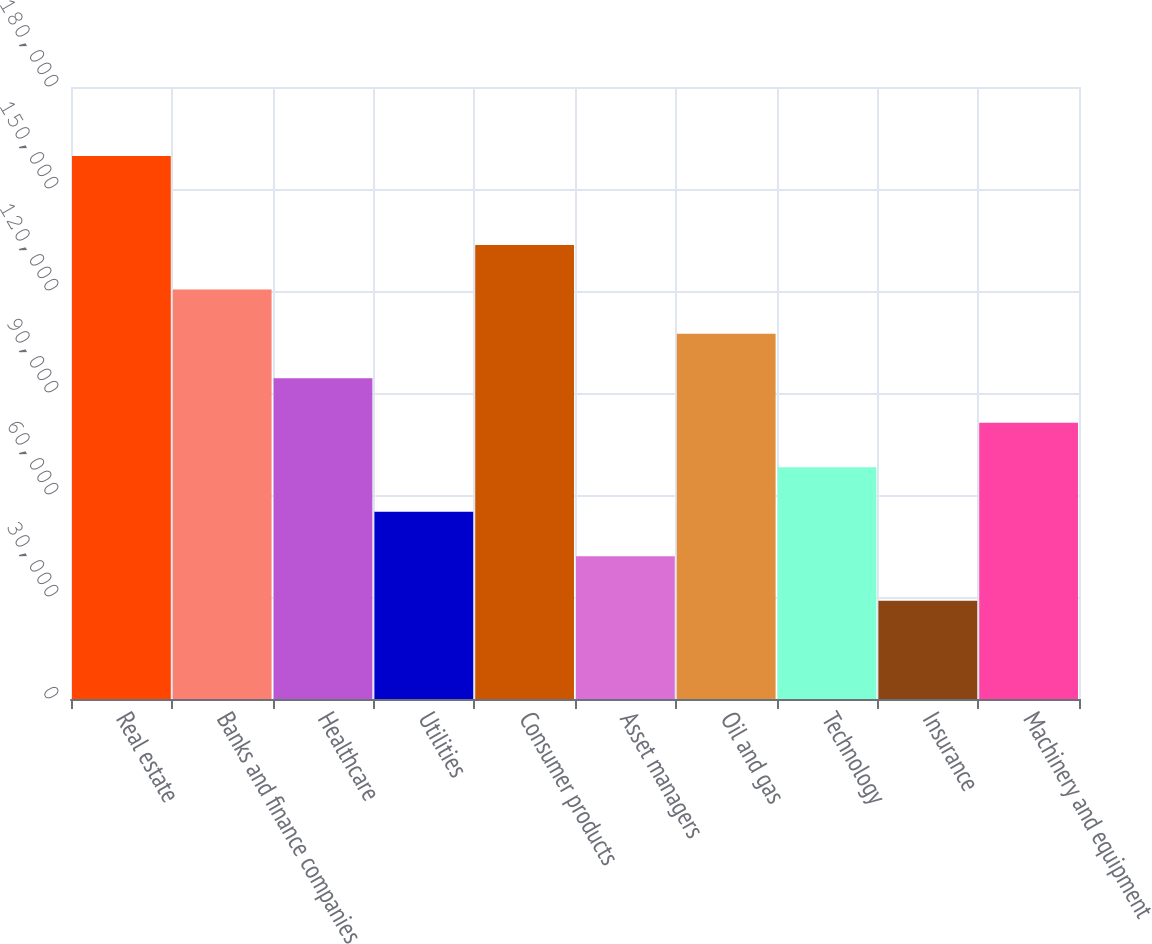Convert chart. <chart><loc_0><loc_0><loc_500><loc_500><bar_chart><fcel>Real estate<fcel>Banks and finance companies<fcel>Healthcare<fcel>Utilities<fcel>Consumer products<fcel>Asset managers<fcel>Oil and gas<fcel>Technology<fcel>Insurance<fcel>Machinery and equipment<nl><fcel>159719<fcel>120476<fcel>94313.4<fcel>55069.8<fcel>133557<fcel>41988.6<fcel>107395<fcel>68151<fcel>28907.4<fcel>81232.2<nl></chart> 